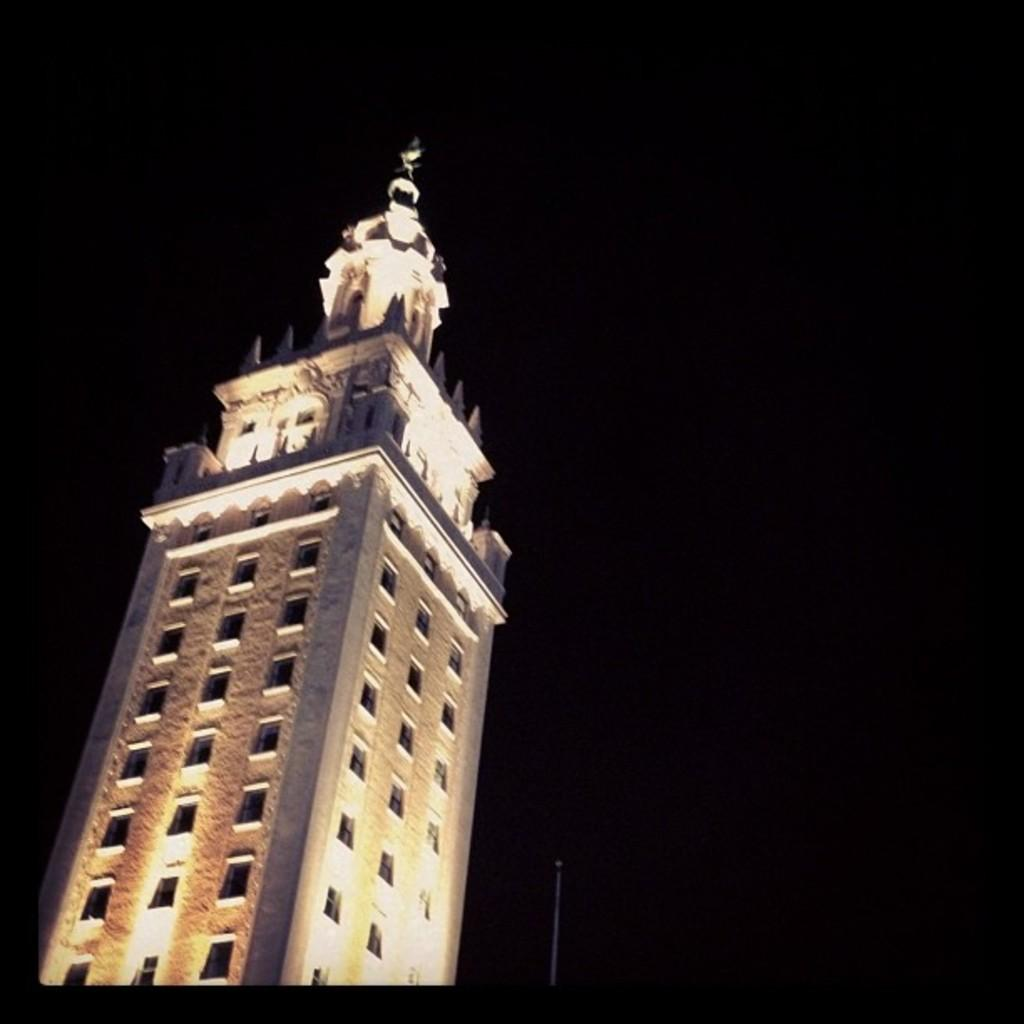What time of day was the image taken? The image was taken during night time. What type of structure is visible in the image? There is a tower building in the image. What other object can be seen in the image? There is a pole in the image. What type of ring can be seen on the tower building in the image? There is no ring present on the tower building in the image. What type of drug is being used by the people in the image? There are no people or drugs present in the image. 